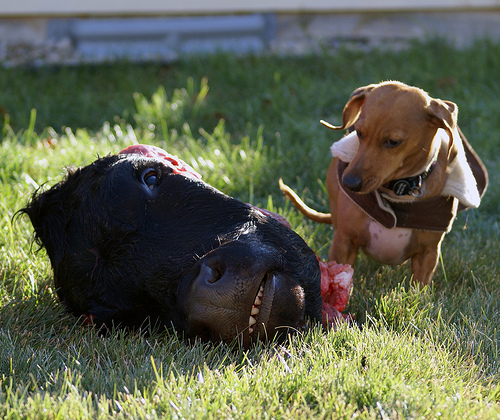<image>
Is there a grass on the dog? No. The grass is not positioned on the dog. They may be near each other, but the grass is not supported by or resting on top of the dog. Is the dog next to the cow? Yes. The dog is positioned adjacent to the cow, located nearby in the same general area. Is the head under the dog? No. The head is not positioned under the dog. The vertical relationship between these objects is different. 